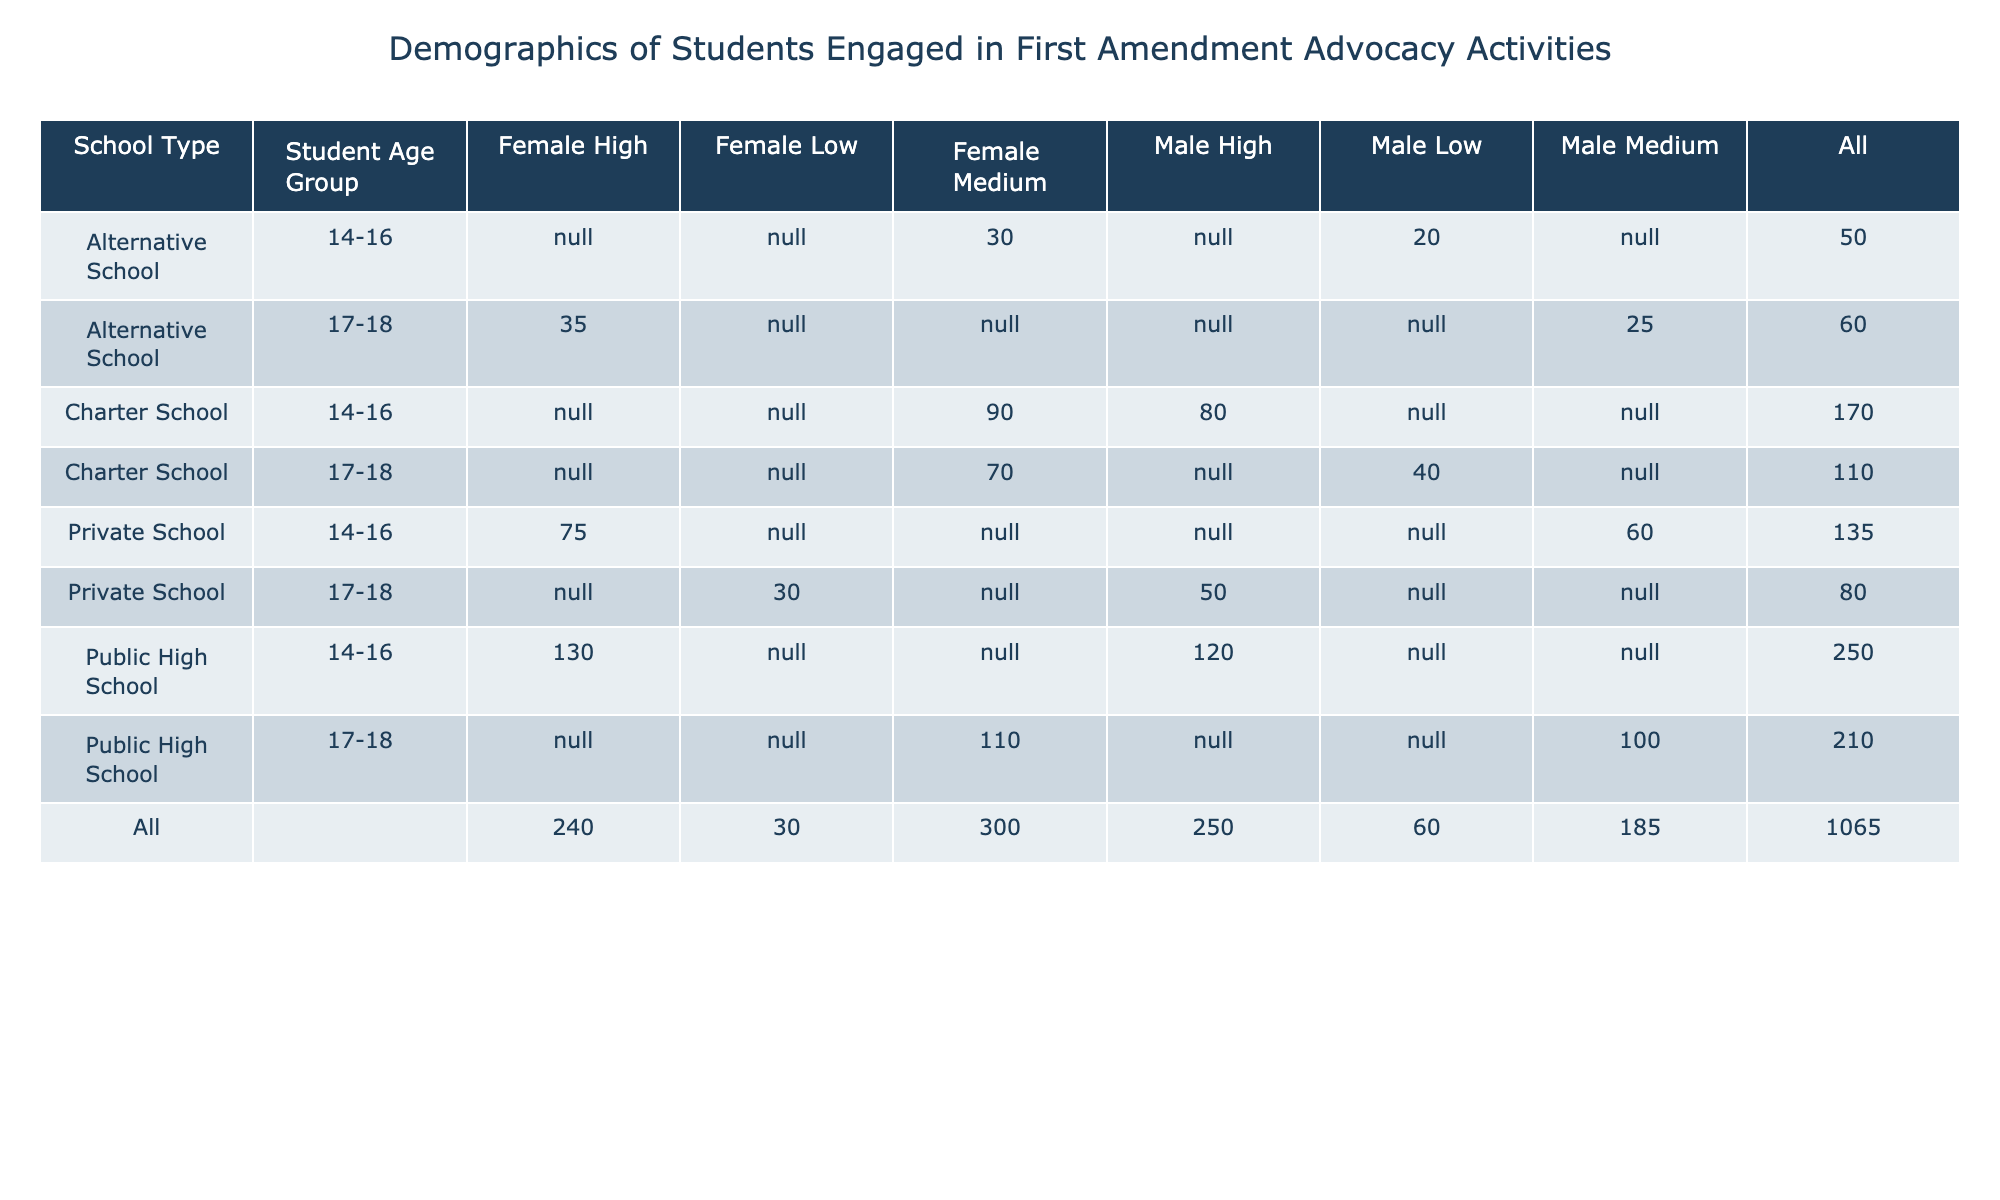What is the total number of participants from Public High Schools? To find the total number of participants from Public High Schools, we look at the relevant rows in the table. For Public High Schools, the participants are 120 (14-16, Male, High), 130 (14-16, Female, High), 100 (17-18, Male, Medium), and 110 (17-18, Female, Medium). Adding these together: 120 + 130 + 100 + 110 = 460.
Answer: 460 Which school type has the highest number of participants in the 17-18 age group? We examine the total number of participants for each school type in the 17-18 age group. The counts are: Public High School (100 + 110 = 210), Charter School (40 + 70 = 110), Private School (50 + 30 = 80), and Alternative School (25 + 35 = 60). The highest total is from Public High Schools with 210 participants.
Answer: Public High School What proportion of female students engaged at high levels in advocacy activities are from Private Schools? First, we identify the counts for female students engaged at high levels. They are 75 (Private School, 14-16) and 0 (Private School, 17-18, Female). Total for females at high level: 130 (Public High) + 75 (Private High) + 35 (Alternative) = 240. The proportion of Private School students is 75/240 = 0.3125, or 31.25%.
Answer: 31.25% Are there any students from Alternative Schools aged 14-16 who participated at a high engagement level? We look specifically at the Alternative School entries for the 14-16 age group. The counts indicate 20 (Male) at a low level and 30 (Female) at a medium level. Since there are no high-level participants listed, the answer is no.
Answer: No What is the average number of participants across all engagement levels for Charter Schools? The numbers for Charter Schools are: 80 (14-16, Male, High), 90 (14-16, Female, Medium), 40 (17-18, Male, Low), and 70 (17-18, Female, Medium). We sum these values: 80 + 90 + 40 + 70 = 280. There are 4 entries, so the average is 280/4 = 70.
Answer: 70 